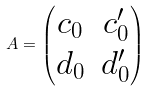Convert formula to latex. <formula><loc_0><loc_0><loc_500><loc_500>A = \begin{pmatrix} c _ { 0 } & c _ { 0 } ^ { \prime } \\ d _ { 0 } & d _ { 0 } ^ { \prime } \end{pmatrix}</formula> 